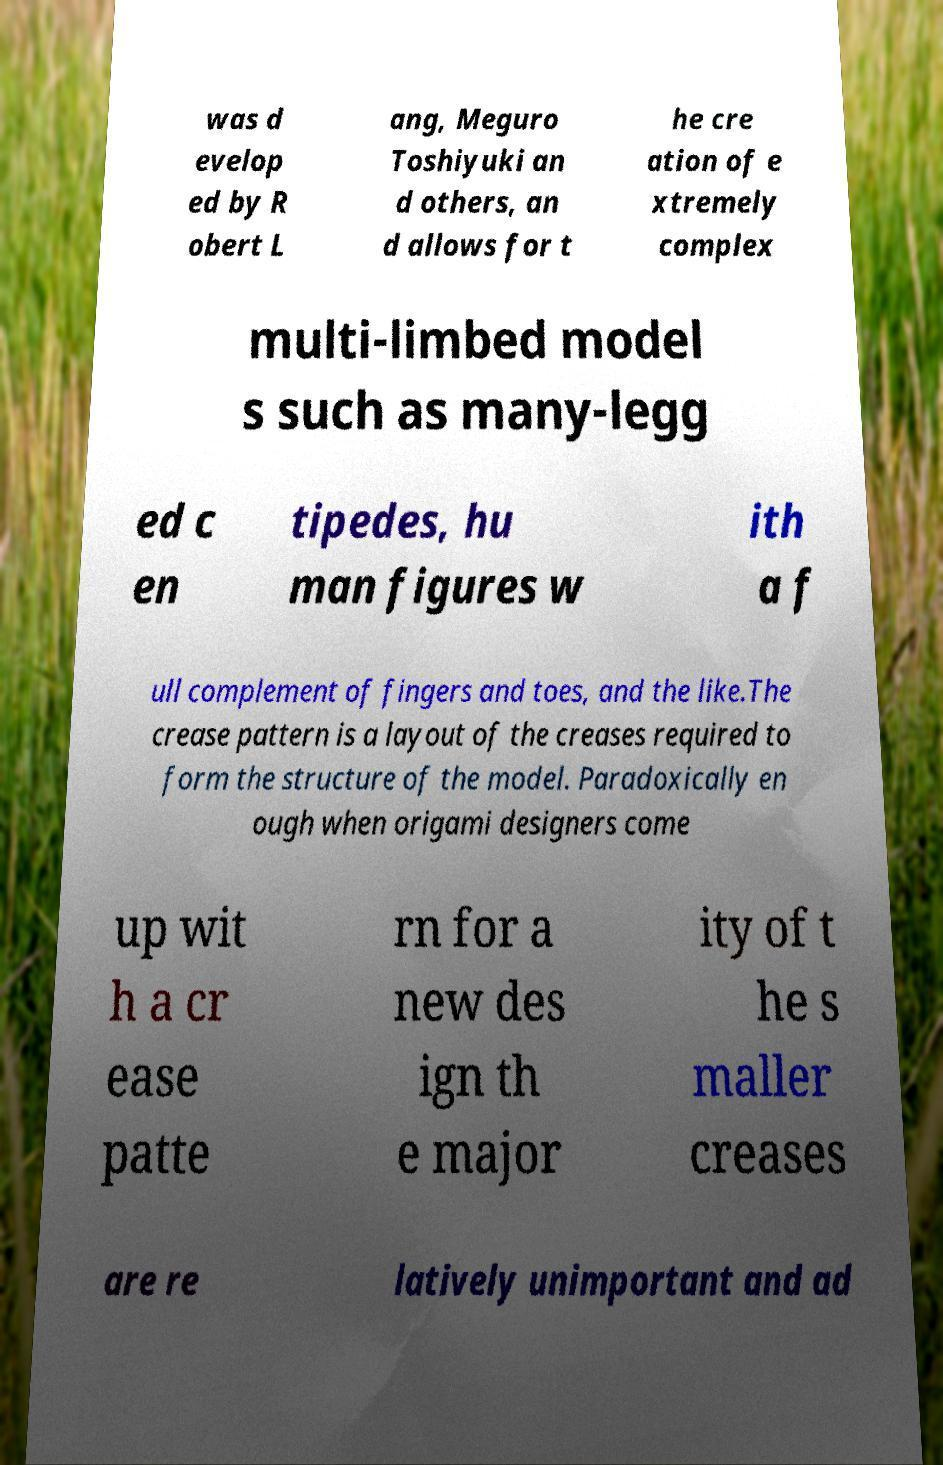Please identify and transcribe the text found in this image. was d evelop ed by R obert L ang, Meguro Toshiyuki an d others, an d allows for t he cre ation of e xtremely complex multi-limbed model s such as many-legg ed c en tipedes, hu man figures w ith a f ull complement of fingers and toes, and the like.The crease pattern is a layout of the creases required to form the structure of the model. Paradoxically en ough when origami designers come up wit h a cr ease patte rn for a new des ign th e major ity of t he s maller creases are re latively unimportant and ad 